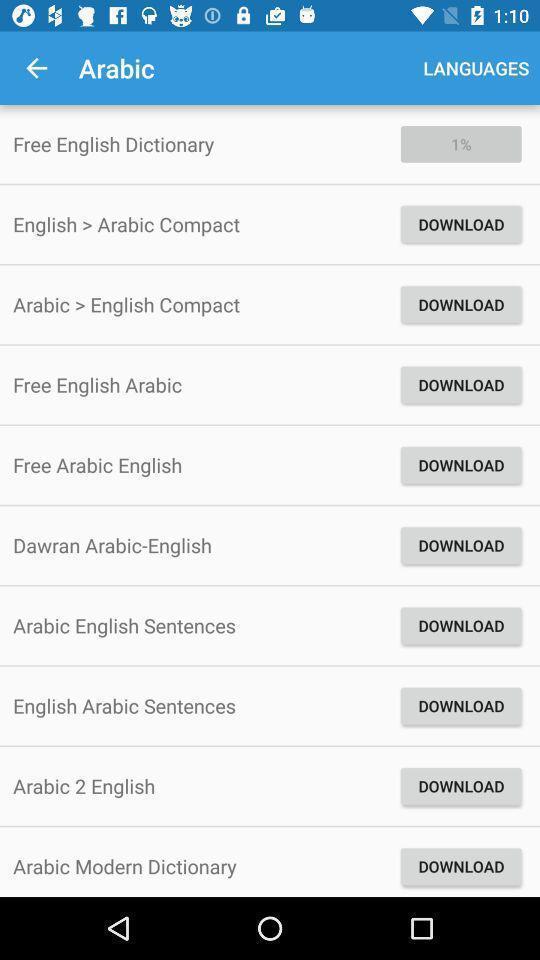Please provide a description for this image. Page displaying list of options. 